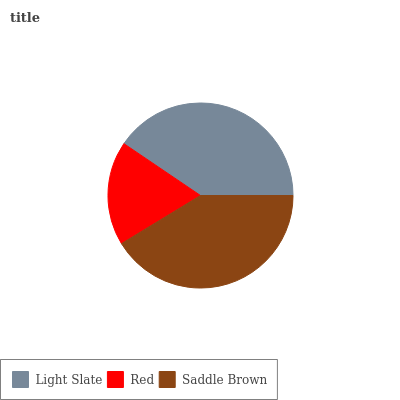Is Red the minimum?
Answer yes or no. Yes. Is Saddle Brown the maximum?
Answer yes or no. Yes. Is Saddle Brown the minimum?
Answer yes or no. No. Is Red the maximum?
Answer yes or no. No. Is Saddle Brown greater than Red?
Answer yes or no. Yes. Is Red less than Saddle Brown?
Answer yes or no. Yes. Is Red greater than Saddle Brown?
Answer yes or no. No. Is Saddle Brown less than Red?
Answer yes or no. No. Is Light Slate the high median?
Answer yes or no. Yes. Is Light Slate the low median?
Answer yes or no. Yes. Is Saddle Brown the high median?
Answer yes or no. No. Is Saddle Brown the low median?
Answer yes or no. No. 